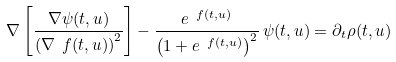<formula> <loc_0><loc_0><loc_500><loc_500>\nabla \left [ \frac { \nabla \psi ( t , u ) } { \left ( \nabla \ f ( t , u ) \right ) ^ { 2 } } \right ] - \frac { e ^ { \ f ( t , u ) } } { \left ( 1 + e ^ { \ f ( t , u ) } \right ) ^ { 2 } } \, \psi ( t , u ) = \partial _ { t } \rho ( t , u )</formula> 